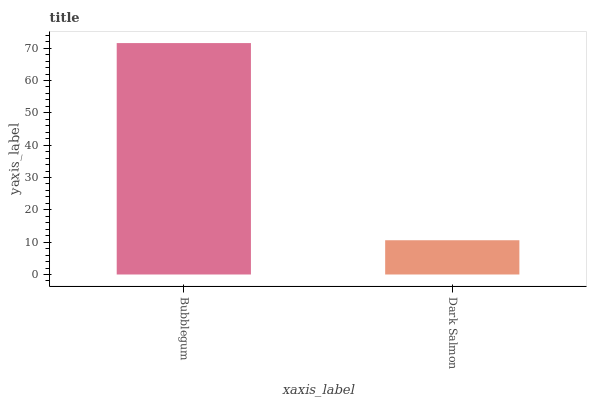Is Dark Salmon the maximum?
Answer yes or no. No. Is Bubblegum greater than Dark Salmon?
Answer yes or no. Yes. Is Dark Salmon less than Bubblegum?
Answer yes or no. Yes. Is Dark Salmon greater than Bubblegum?
Answer yes or no. No. Is Bubblegum less than Dark Salmon?
Answer yes or no. No. Is Bubblegum the high median?
Answer yes or no. Yes. Is Dark Salmon the low median?
Answer yes or no. Yes. Is Dark Salmon the high median?
Answer yes or no. No. Is Bubblegum the low median?
Answer yes or no. No. 